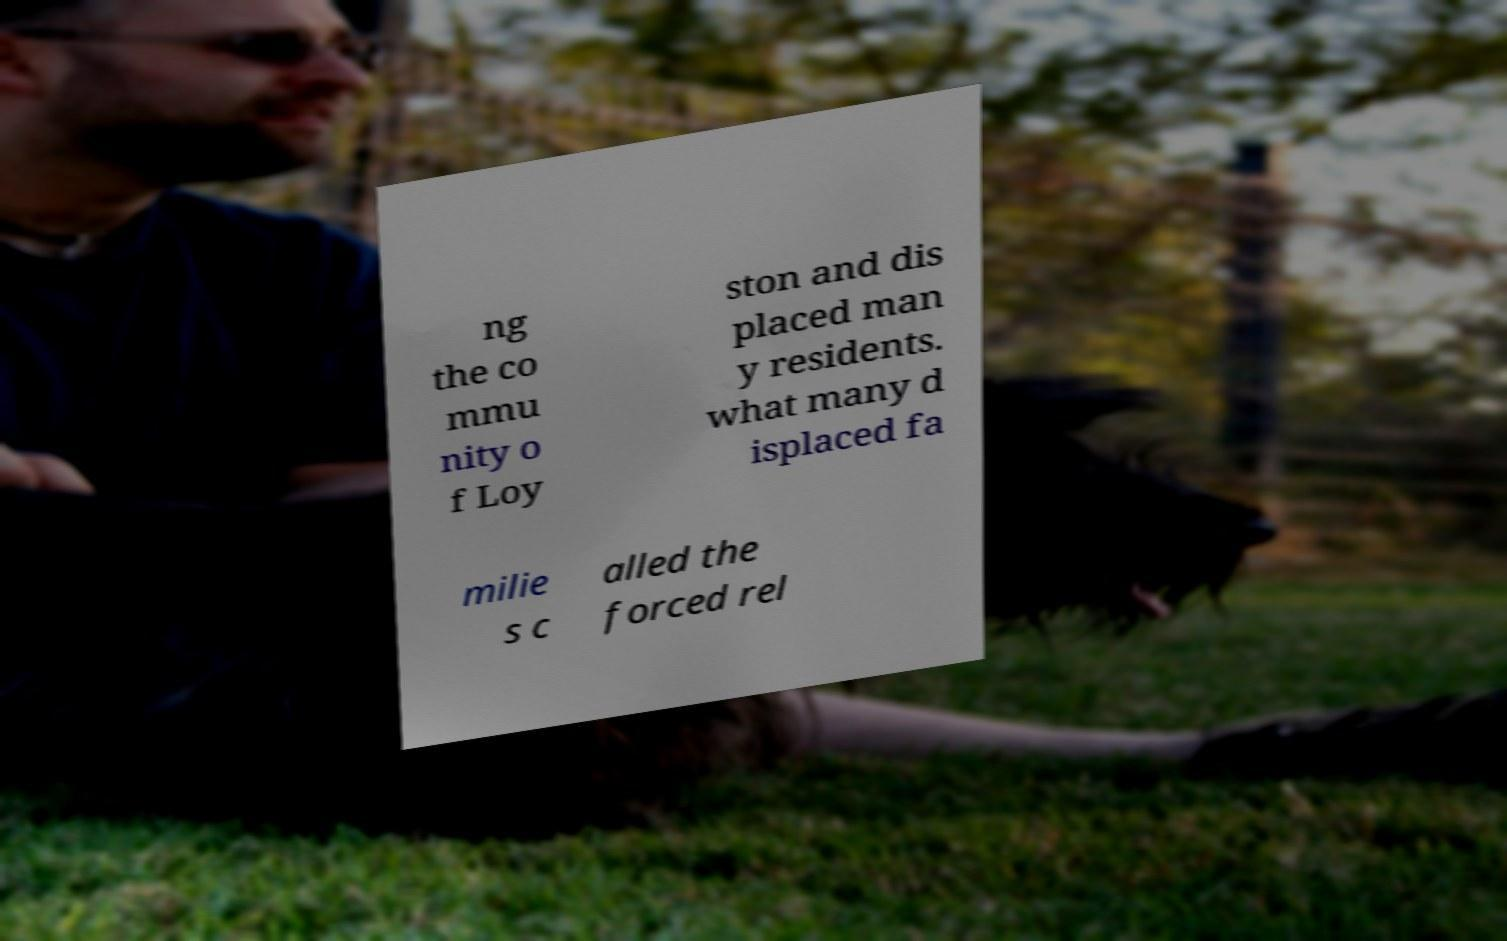Please identify and transcribe the text found in this image. ng the co mmu nity o f Loy ston and dis placed man y residents. what many d isplaced fa milie s c alled the forced rel 